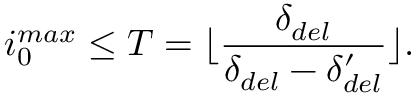Convert formula to latex. <formula><loc_0><loc_0><loc_500><loc_500>i _ { 0 } ^ { \max } \leq T = \lfloor \frac { \delta _ { d e l } } { \delta _ { d e l } - \delta _ { d e l } ^ { \prime } } \rfloor .</formula> 